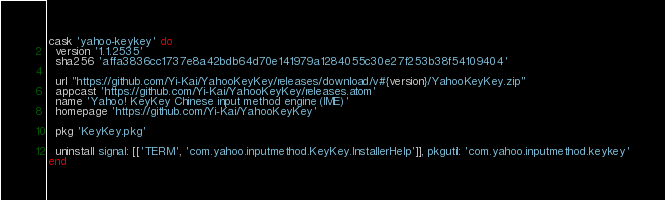<code> <loc_0><loc_0><loc_500><loc_500><_Ruby_>cask 'yahoo-keykey' do
  version '1.1.2535'
  sha256 'affa3836cc1737e8a42bdb64d70e141979a1284055c30e27f253b38f54109404'

  url "https://github.com/Yi-Kai/YahooKeyKey/releases/download/v#{version}/YahooKeyKey.zip"
  appcast 'https://github.com/Yi-Kai/YahooKeyKey/releases.atom'
  name 'Yahoo! KeyKey Chinese input method engine (IME)'
  homepage 'https://github.com/Yi-Kai/YahooKeyKey'

  pkg 'KeyKey.pkg'

  uninstall signal: [['TERM', 'com.yahoo.inputmethod.KeyKey.InstallerHelp']], pkgutil: 'com.yahoo.inputmethod.keykey'
end
</code> 